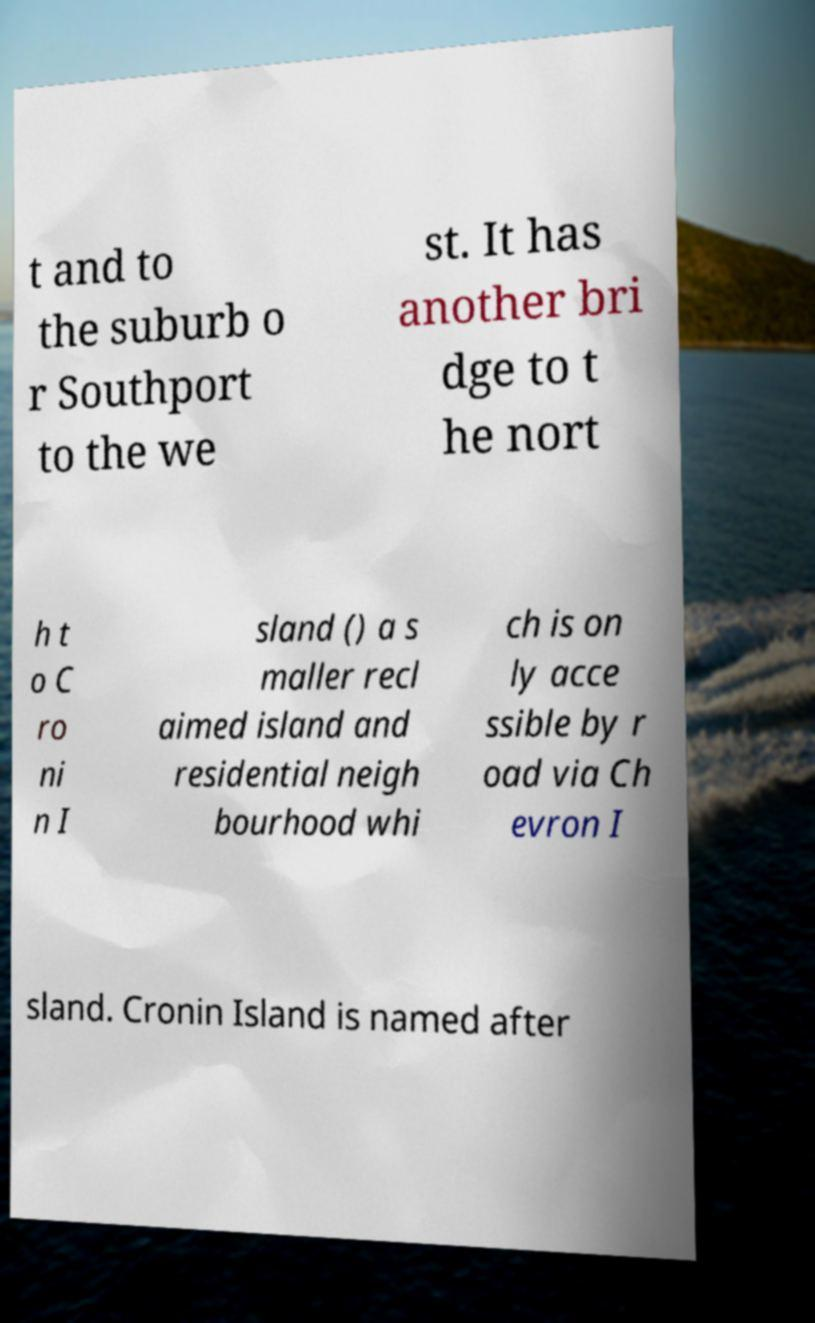Could you extract and type out the text from this image? t and to the suburb o r Southport to the we st. It has another bri dge to t he nort h t o C ro ni n I sland () a s maller recl aimed island and residential neigh bourhood whi ch is on ly acce ssible by r oad via Ch evron I sland. Cronin Island is named after 